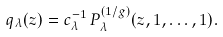<formula> <loc_0><loc_0><loc_500><loc_500>q _ { \lambda } ( z ) = c _ { \lambda } ^ { - 1 } \, P _ { \lambda } ^ { ( 1 / g ) } ( z , 1 , \dots , 1 ) .</formula> 